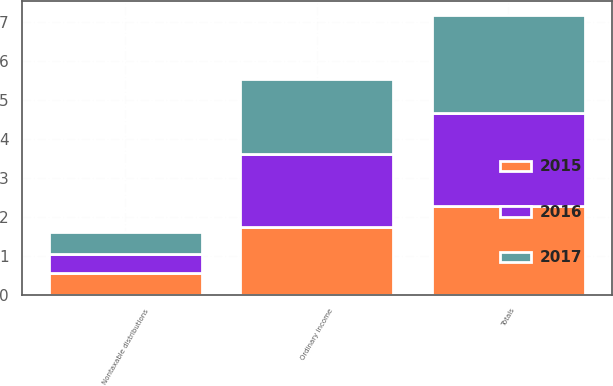Convert chart. <chart><loc_0><loc_0><loc_500><loc_500><stacked_bar_chart><ecel><fcel>Ordinary income<fcel>Nontaxable distributions<fcel>Totals<nl><fcel>2017<fcel>1.94<fcel>0.55<fcel>2.53<nl><fcel>2016<fcel>1.88<fcel>0.51<fcel>2.39<nl><fcel>2015<fcel>1.73<fcel>0.54<fcel>2.27<nl></chart> 